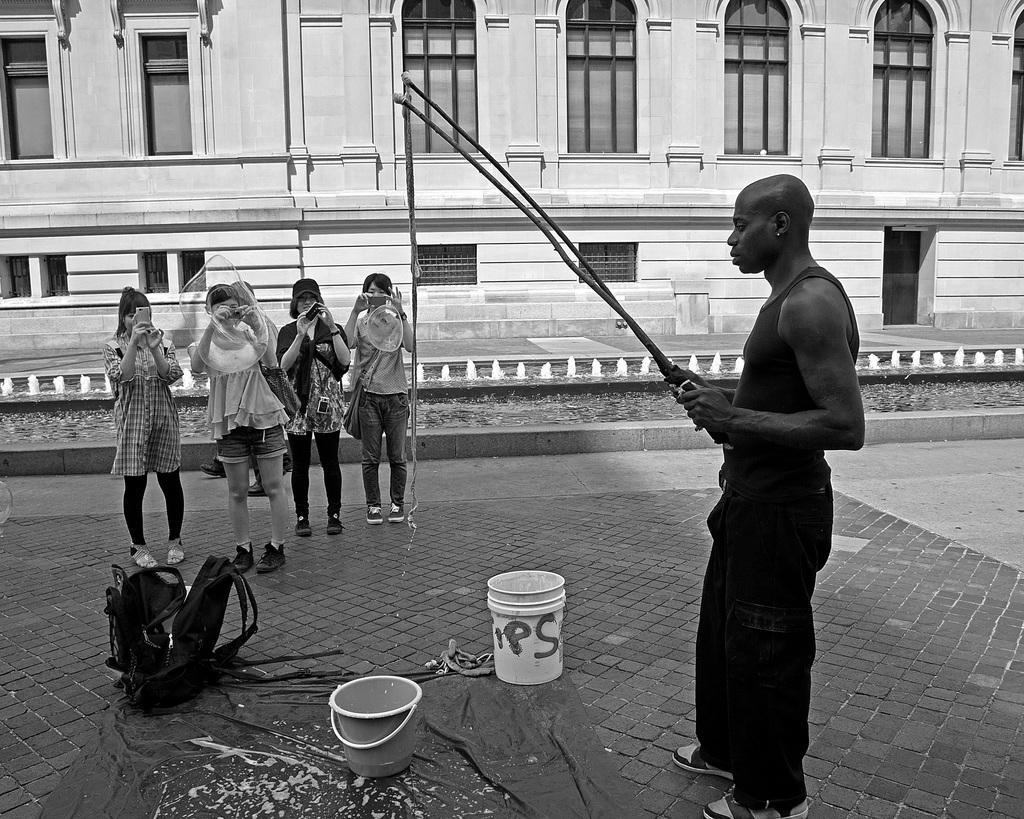Describe this image in one or two sentences. This is a black and white image. In this image there is a man holding rods. In front of him there is a sheet. On that there are buckets. Also there is a bag. Also there are few people standing and holding mobile. In the background there is a building with windows and arches. 